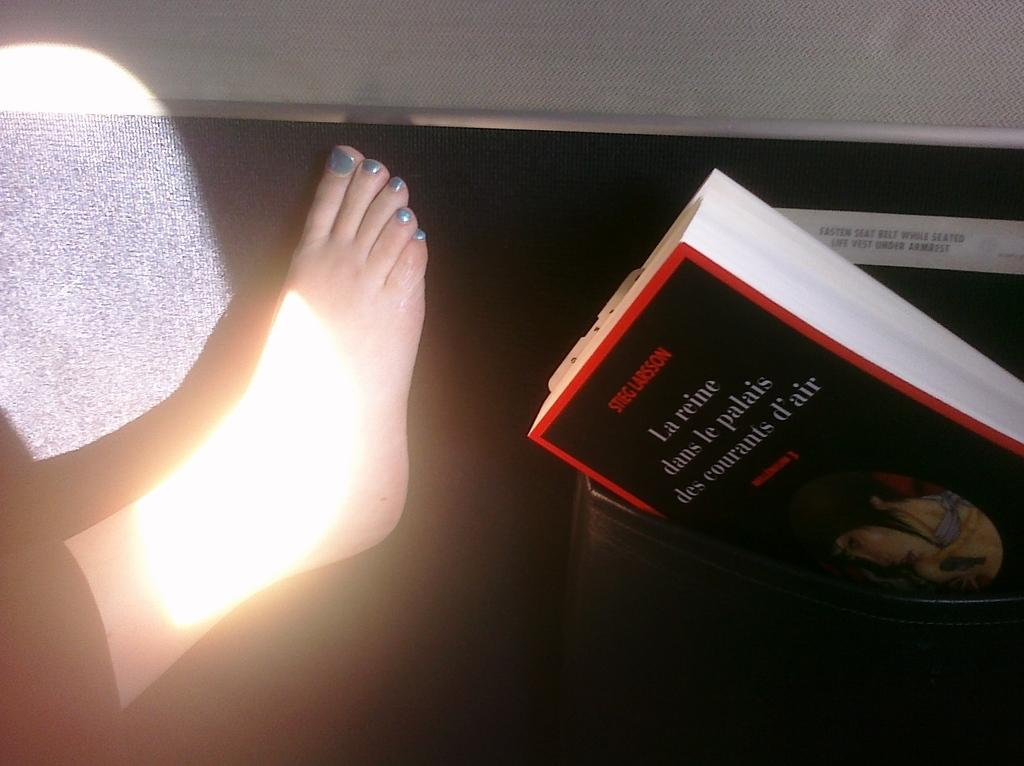<image>
Present a compact description of the photo's key features. A Stieg Larsson book is in a purse next to a foot with blue painted toenails. 